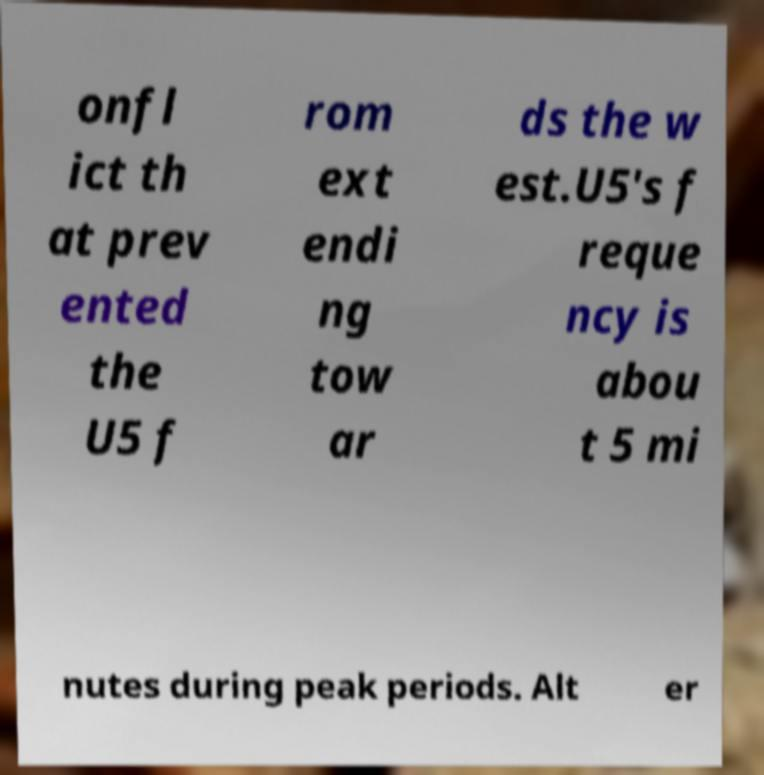Please identify and transcribe the text found in this image. onfl ict th at prev ented the U5 f rom ext endi ng tow ar ds the w est.U5's f reque ncy is abou t 5 mi nutes during peak periods. Alt er 